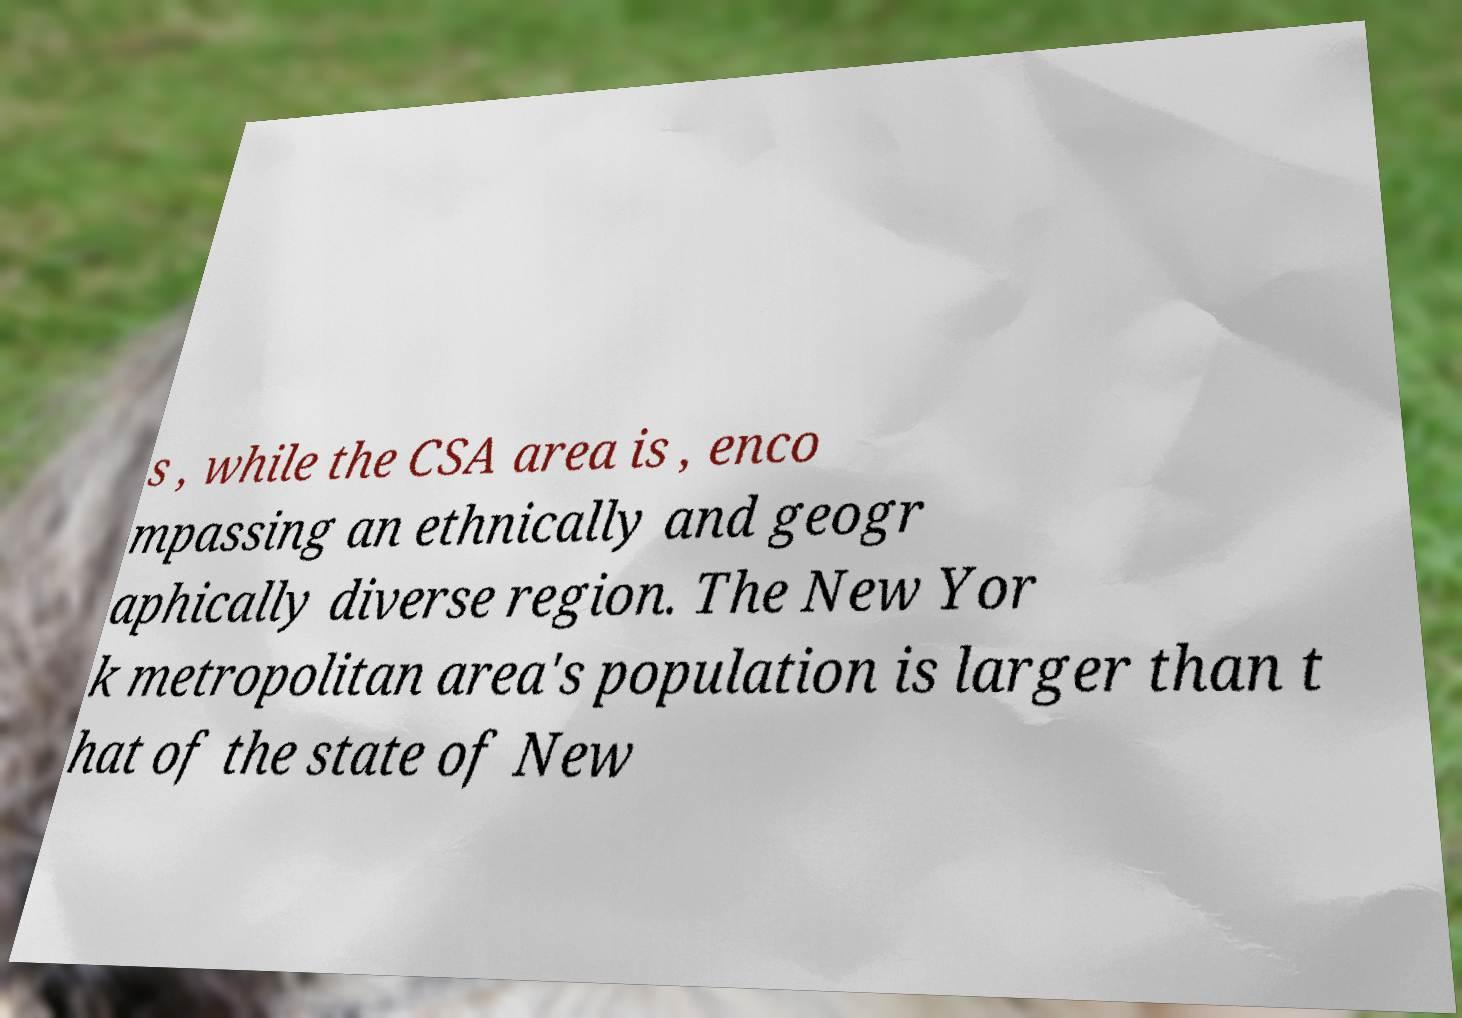There's text embedded in this image that I need extracted. Can you transcribe it verbatim? s , while the CSA area is , enco mpassing an ethnically and geogr aphically diverse region. The New Yor k metropolitan area's population is larger than t hat of the state of New 